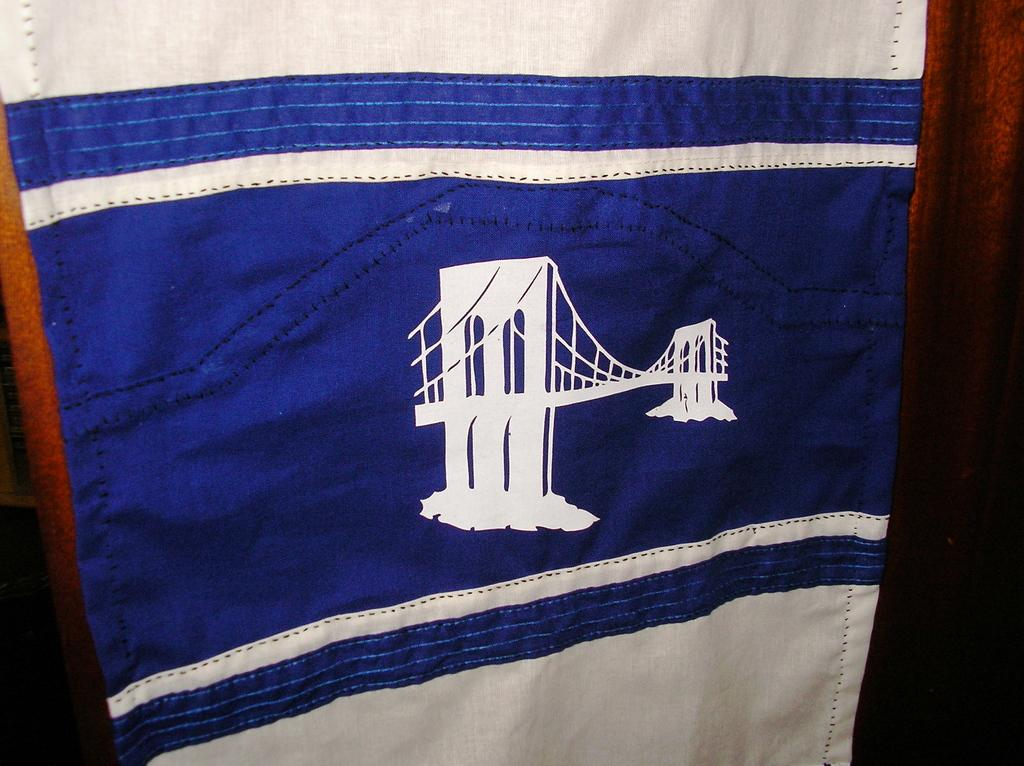What is the main object in the center of the image? There is a cloth in the center of the image. What type of material is the wall in the background made of? The wall in the background is made of wood. What type of carriage is parked next to the wooden wall in the image? There is no carriage present in the image; it only features a cloth in the center and a wooden wall in the background. 